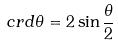Convert formula to latex. <formula><loc_0><loc_0><loc_500><loc_500>c r d \theta = 2 \sin \frac { \theta } { 2 }</formula> 